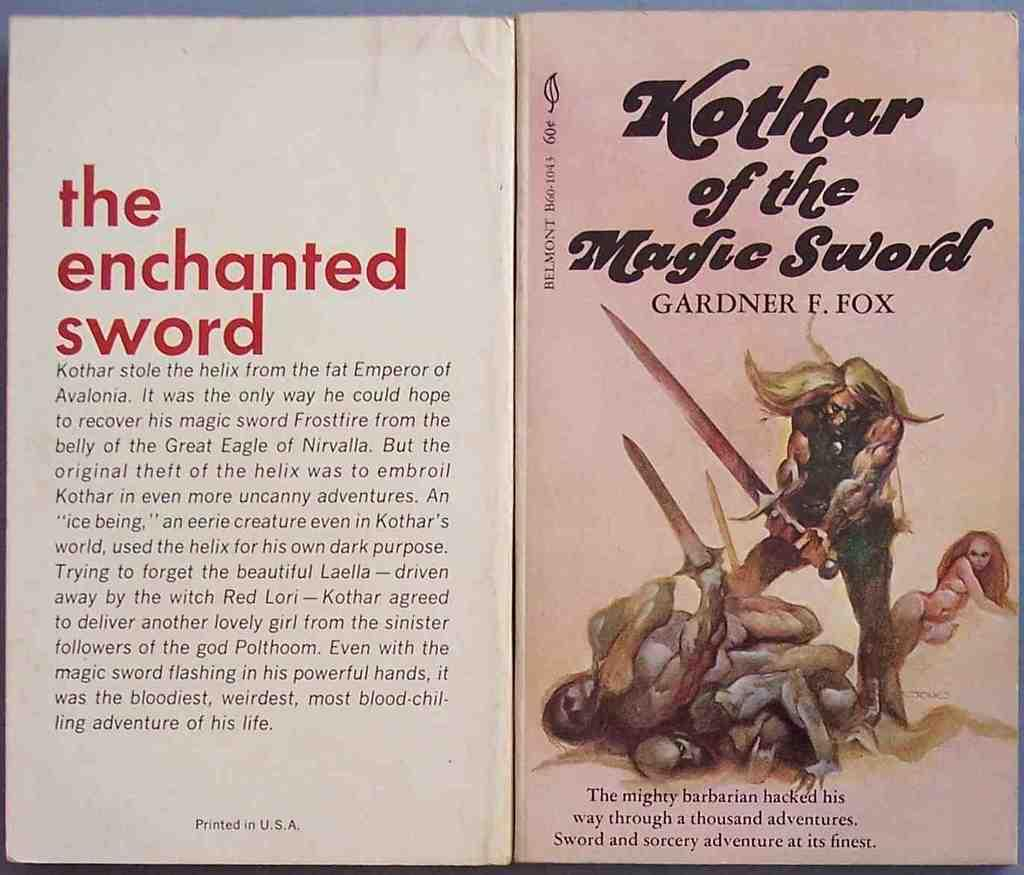<image>
Present a compact description of the photo's key features. The might barbarian Kothar of the Magic Sword book. 